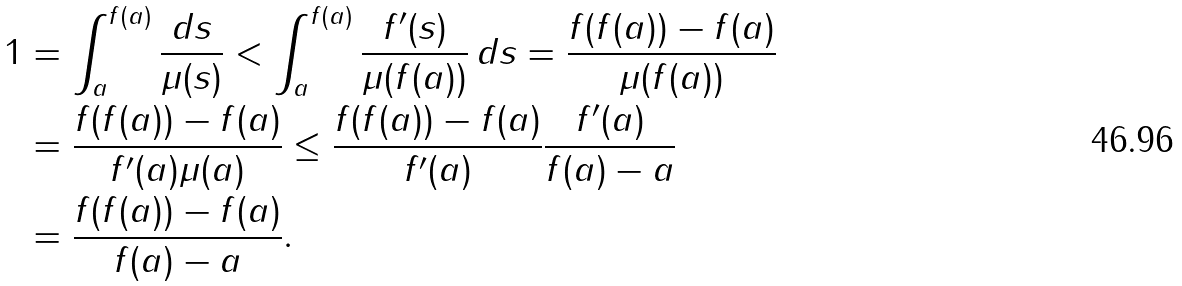<formula> <loc_0><loc_0><loc_500><loc_500>1 & = \int _ { a } ^ { f ( a ) } \frac { d s } { \mu ( s ) } < \int _ { a } ^ { f ( a ) } \frac { f ^ { \prime } ( s ) } { \mu ( f ( a ) ) } \, d s = \frac { f ( f ( a ) ) - f ( a ) } { \mu ( f ( a ) ) } \\ & = \frac { f ( f ( a ) ) - f ( a ) } { f ^ { \prime } ( a ) \mu ( a ) } \leq \frac { f ( f ( a ) ) - f ( a ) } { f ^ { \prime } ( a ) } \frac { f ^ { \prime } ( a ) } { f ( a ) - a } \\ & = \frac { f ( f ( a ) ) - f ( a ) } { f ( a ) - a } .</formula> 